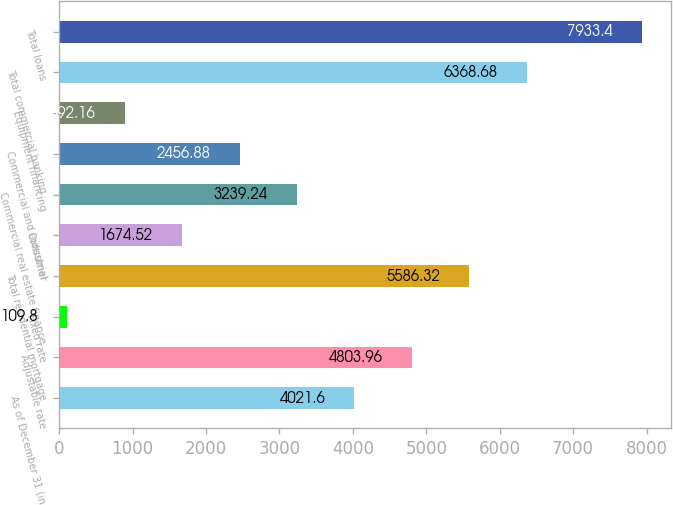<chart> <loc_0><loc_0><loc_500><loc_500><bar_chart><fcel>As of December 31 (in<fcel>Adjustable rate<fcel>Fixed rate<fcel>Total residential mortgage<fcel>Consumer<fcel>Commercial real estate finance<fcel>Commercial and industrial<fcel>Equipment financing<fcel>Total commercial banking<fcel>Total loans<nl><fcel>4021.6<fcel>4803.96<fcel>109.8<fcel>5586.32<fcel>1674.52<fcel>3239.24<fcel>2456.88<fcel>892.16<fcel>6368.68<fcel>7933.4<nl></chart> 